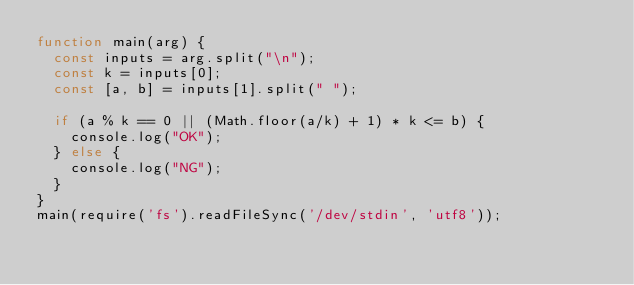<code> <loc_0><loc_0><loc_500><loc_500><_JavaScript_>function main(arg) {
  const inputs = arg.split("\n");
  const k = inputs[0];
  const [a, b] = inputs[1].split(" ");
  
  if (a % k == 0 || (Math.floor(a/k) + 1) * k <= b) {
    console.log("OK");
  } else {
    console.log("NG");
  }
}
main(require('fs').readFileSync('/dev/stdin', 'utf8'));</code> 